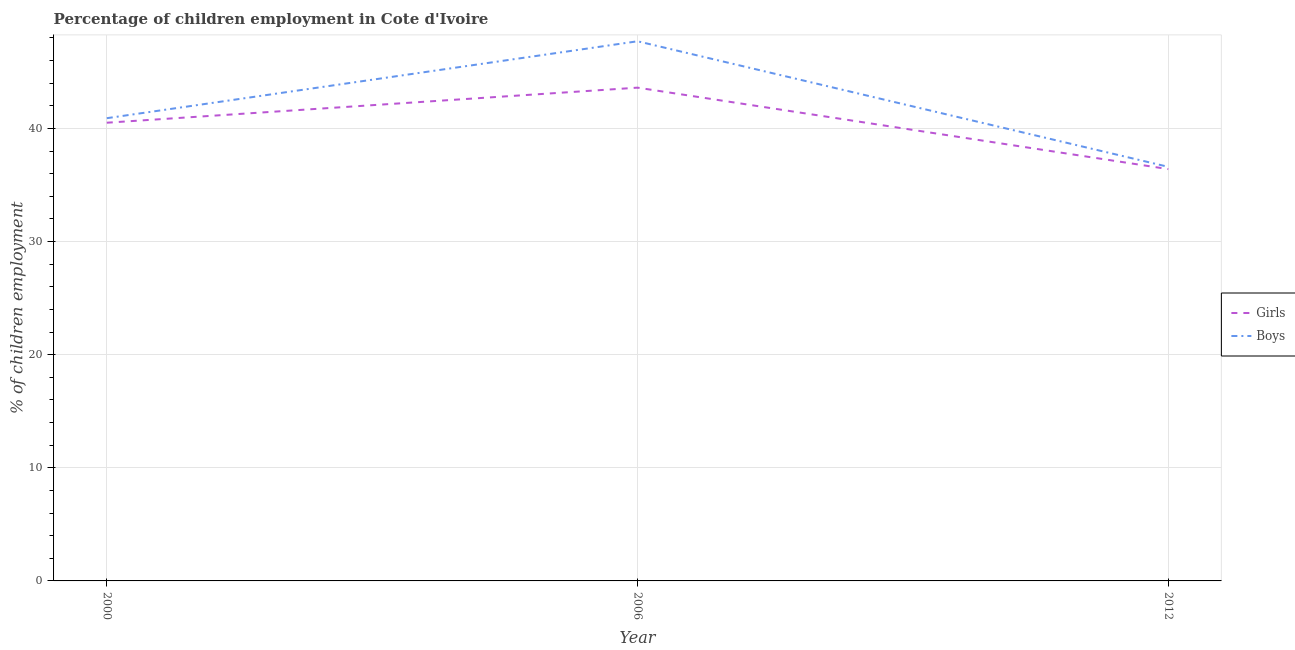What is the percentage of employed girls in 2006?
Provide a short and direct response. 43.6. Across all years, what is the maximum percentage of employed girls?
Your response must be concise. 43.6. Across all years, what is the minimum percentage of employed boys?
Provide a short and direct response. 36.6. In which year was the percentage of employed girls maximum?
Your answer should be compact. 2006. In which year was the percentage of employed boys minimum?
Your answer should be very brief. 2012. What is the total percentage of employed boys in the graph?
Give a very brief answer. 125.2. What is the difference between the percentage of employed boys in 2000 and that in 2006?
Your answer should be very brief. -6.8. What is the difference between the percentage of employed girls in 2006 and the percentage of employed boys in 2000?
Your answer should be compact. 2.7. What is the average percentage of employed boys per year?
Ensure brevity in your answer.  41.73. In the year 2006, what is the difference between the percentage of employed girls and percentage of employed boys?
Offer a terse response. -4.1. In how many years, is the percentage of employed girls greater than 40 %?
Offer a terse response. 2. What is the ratio of the percentage of employed boys in 2006 to that in 2012?
Your answer should be very brief. 1.3. What is the difference between the highest and the second highest percentage of employed girls?
Keep it short and to the point. 3.1. What is the difference between the highest and the lowest percentage of employed girls?
Provide a short and direct response. 7.2. Does the percentage of employed boys monotonically increase over the years?
Offer a terse response. No. Is the percentage of employed boys strictly less than the percentage of employed girls over the years?
Offer a very short reply. No. How many lines are there?
Make the answer very short. 2. What is the difference between two consecutive major ticks on the Y-axis?
Your answer should be compact. 10. Does the graph contain any zero values?
Provide a short and direct response. No. Does the graph contain grids?
Ensure brevity in your answer.  Yes. What is the title of the graph?
Your response must be concise. Percentage of children employment in Cote d'Ivoire. What is the label or title of the Y-axis?
Make the answer very short. % of children employment. What is the % of children employment of Girls in 2000?
Give a very brief answer. 40.5. What is the % of children employment in Boys in 2000?
Offer a very short reply. 40.9. What is the % of children employment in Girls in 2006?
Keep it short and to the point. 43.6. What is the % of children employment of Boys in 2006?
Provide a short and direct response. 47.7. What is the % of children employment in Girls in 2012?
Offer a very short reply. 36.4. What is the % of children employment of Boys in 2012?
Provide a short and direct response. 36.6. Across all years, what is the maximum % of children employment of Girls?
Provide a short and direct response. 43.6. Across all years, what is the maximum % of children employment of Boys?
Keep it short and to the point. 47.7. Across all years, what is the minimum % of children employment in Girls?
Your answer should be compact. 36.4. Across all years, what is the minimum % of children employment in Boys?
Provide a succinct answer. 36.6. What is the total % of children employment of Girls in the graph?
Your answer should be compact. 120.5. What is the total % of children employment in Boys in the graph?
Keep it short and to the point. 125.2. What is the difference between the % of children employment in Girls in 2000 and that in 2006?
Give a very brief answer. -3.1. What is the difference between the % of children employment in Girls in 2000 and that in 2012?
Offer a very short reply. 4.1. What is the difference between the % of children employment in Boys in 2000 and that in 2012?
Provide a short and direct response. 4.3. What is the difference between the % of children employment in Girls in 2006 and that in 2012?
Offer a terse response. 7.2. What is the difference between the % of children employment of Boys in 2006 and that in 2012?
Make the answer very short. 11.1. What is the difference between the % of children employment of Girls in 2000 and the % of children employment of Boys in 2006?
Provide a short and direct response. -7.2. What is the difference between the % of children employment in Girls in 2000 and the % of children employment in Boys in 2012?
Make the answer very short. 3.9. What is the difference between the % of children employment in Girls in 2006 and the % of children employment in Boys in 2012?
Keep it short and to the point. 7. What is the average % of children employment in Girls per year?
Provide a succinct answer. 40.17. What is the average % of children employment in Boys per year?
Offer a very short reply. 41.73. In the year 2000, what is the difference between the % of children employment of Girls and % of children employment of Boys?
Ensure brevity in your answer.  -0.4. In the year 2012, what is the difference between the % of children employment of Girls and % of children employment of Boys?
Your answer should be compact. -0.2. What is the ratio of the % of children employment of Girls in 2000 to that in 2006?
Keep it short and to the point. 0.93. What is the ratio of the % of children employment of Boys in 2000 to that in 2006?
Provide a succinct answer. 0.86. What is the ratio of the % of children employment in Girls in 2000 to that in 2012?
Your answer should be very brief. 1.11. What is the ratio of the % of children employment in Boys in 2000 to that in 2012?
Offer a very short reply. 1.12. What is the ratio of the % of children employment in Girls in 2006 to that in 2012?
Offer a very short reply. 1.2. What is the ratio of the % of children employment of Boys in 2006 to that in 2012?
Provide a short and direct response. 1.3. 